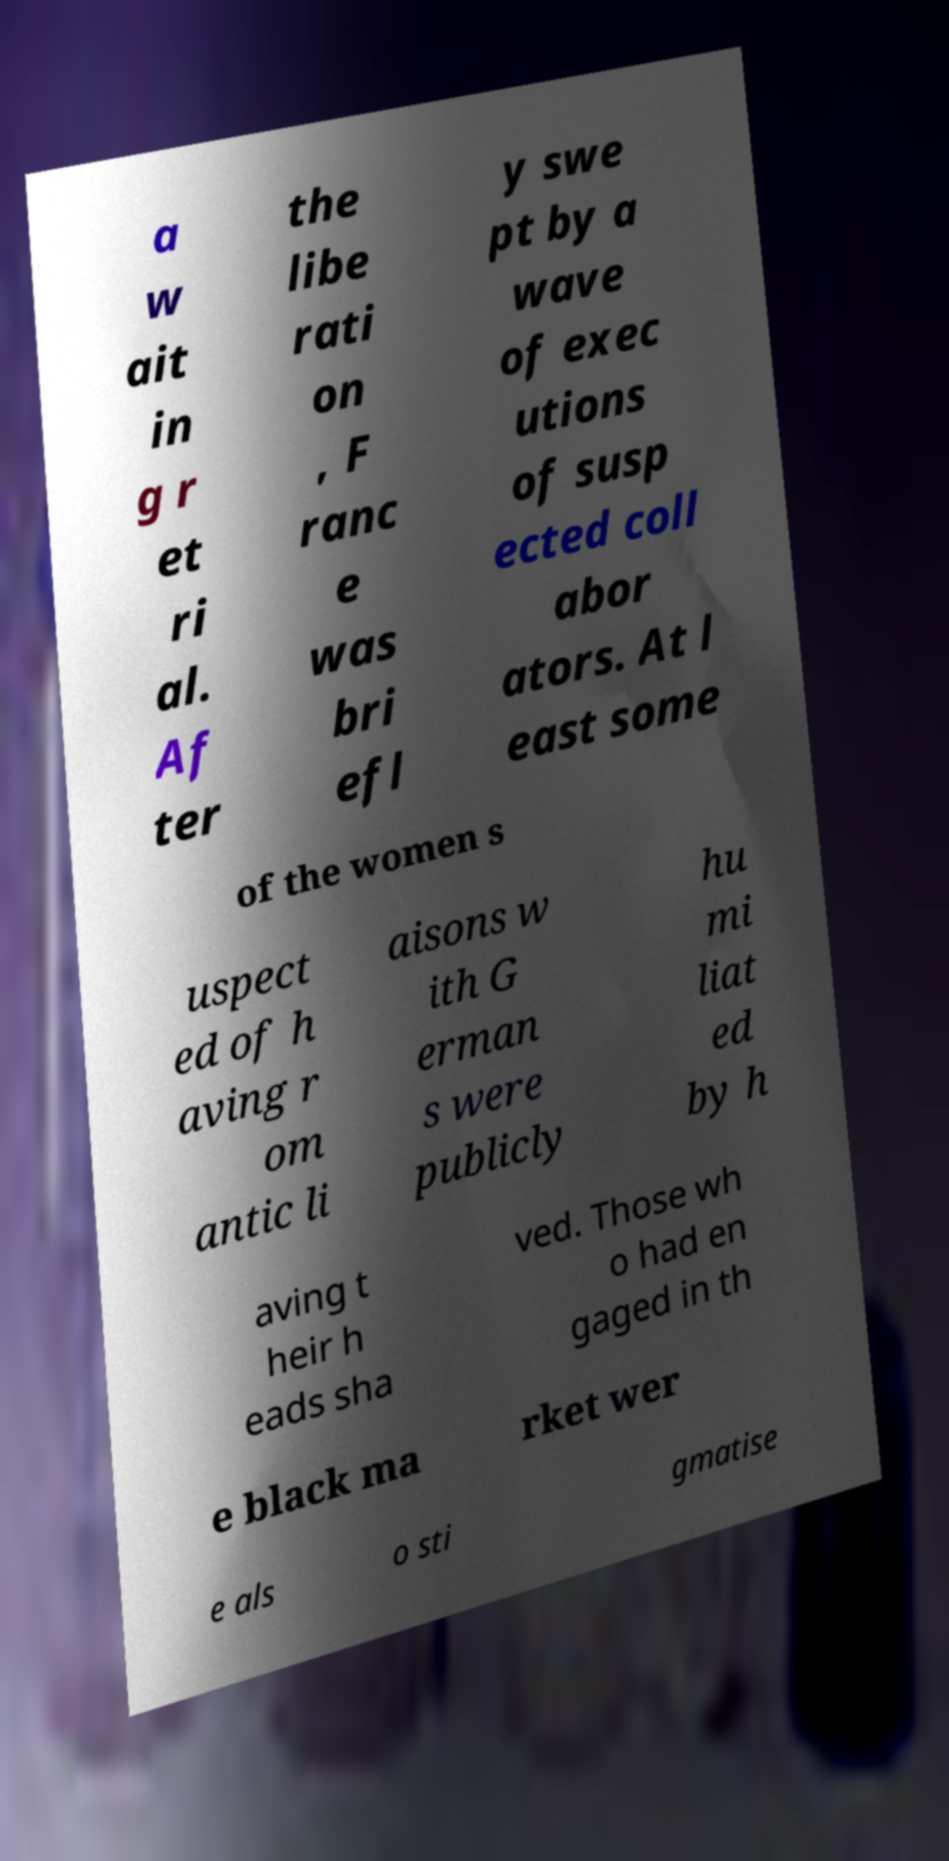There's text embedded in this image that I need extracted. Can you transcribe it verbatim? a w ait in g r et ri al. Af ter the libe rati on , F ranc e was bri efl y swe pt by a wave of exec utions of susp ected coll abor ators. At l east some of the women s uspect ed of h aving r om antic li aisons w ith G erman s were publicly hu mi liat ed by h aving t heir h eads sha ved. Those wh o had en gaged in th e black ma rket wer e als o sti gmatise 